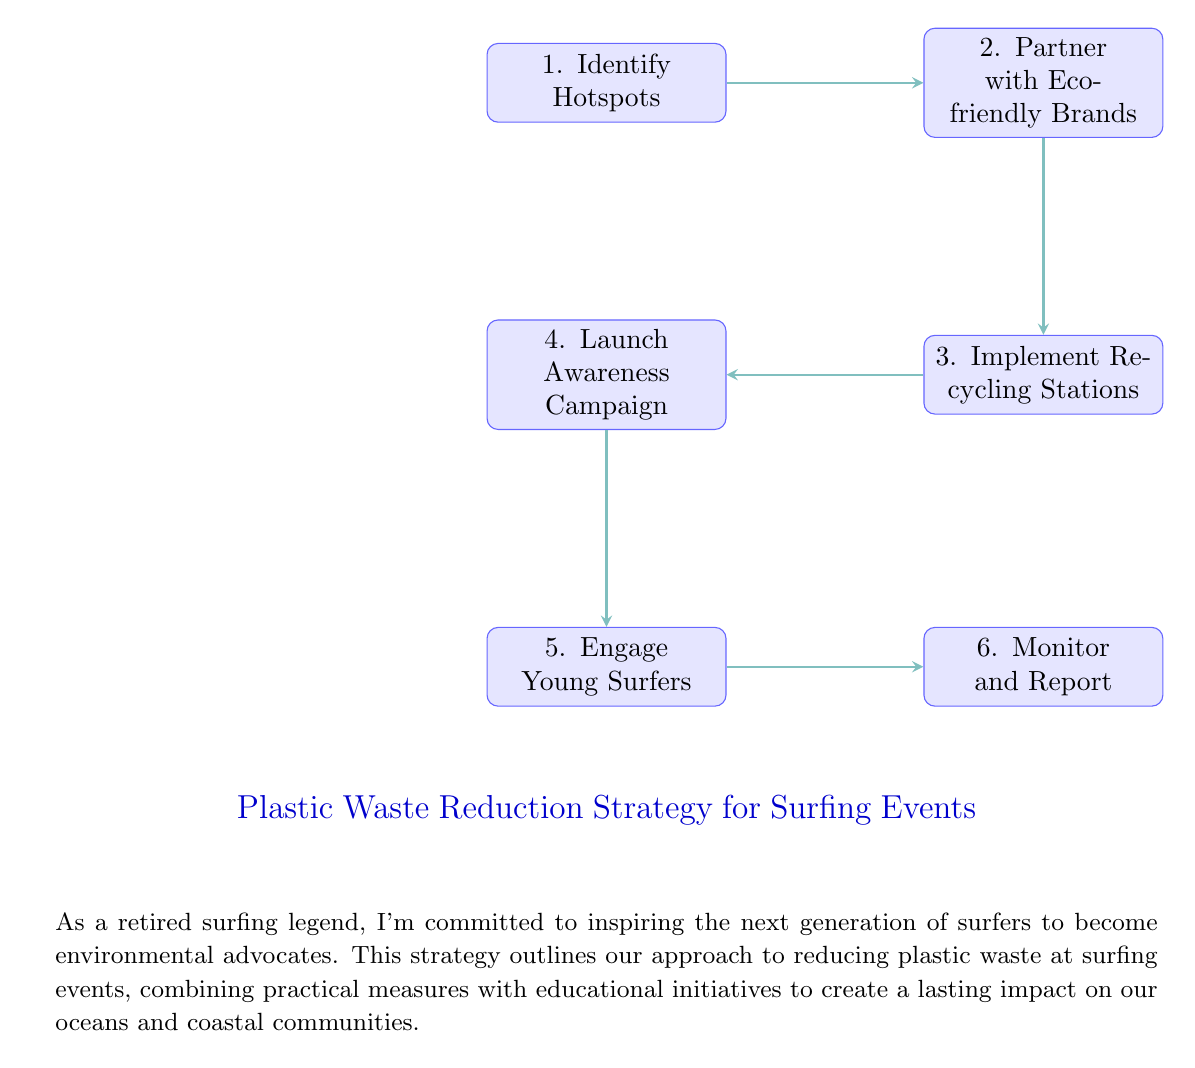What is the first step in the plastic waste reduction strategy? The first step is represented by the topmost node in the flow chart, which is "Identify Hotspots."
Answer: Identify Hotspots How many total nodes are in the flow chart? By counting the number of distinct processes represented in the flow chart, we find there are six nodes: Identify Hotspots, Partner with Eco-friendly Brands, Implement Recycling Stations, Launch Awareness Campaign, Engage Young Surfers, and Monitor and Report.
Answer: Six Which node follows "Implement Recycling Stations"? By following the arrows indicating the flow of actions, the node that follows "Implement Recycling Stations" is "Launch Awareness Campaign."
Answer: Launch Awareness Campaign What is the connection between "Partner with Eco-friendly Brands" and "Implement Recycling Stations"? The connection is a directed arrow indicating a sequential relationship where "Partner with Eco-friendly Brands" leads to "Implement Recycling Stations."
Answer: Leads to Which node is the final action in the process? The last node in the flow chart based on the progression outlined is "Monitor and Report."
Answer: Monitor and Report What is the focus of the campaign launched in the third step? The focus of the campaign is on raising awareness about the impact of plastic waste on oceans, as indicated in the description of the "Launch Awareness Campaign" node.
Answer: Impact of plastic waste on oceans 